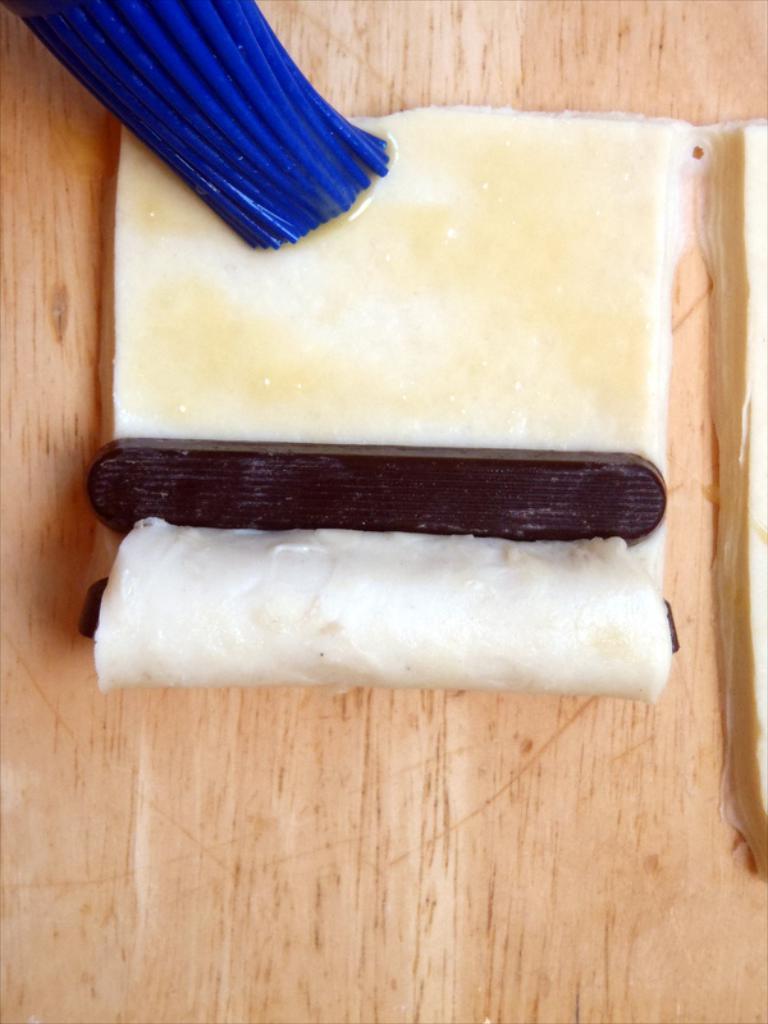Please provide a concise description of this image. In this image, we can see a table. On that table, we can see some food item and a blue color brush. 